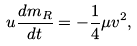<formula> <loc_0><loc_0><loc_500><loc_500>u \frac { d m _ { R } } { d t } = - \frac { 1 } { 4 } \mu v ^ { 2 } ,</formula> 